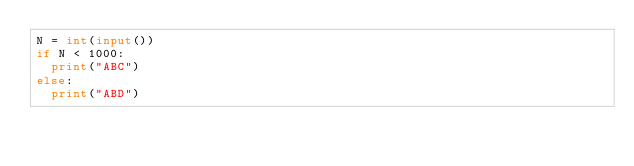Convert code to text. <code><loc_0><loc_0><loc_500><loc_500><_Python_>N = int(input())
if N < 1000:
  print("ABC")
else:
  print("ABD")</code> 